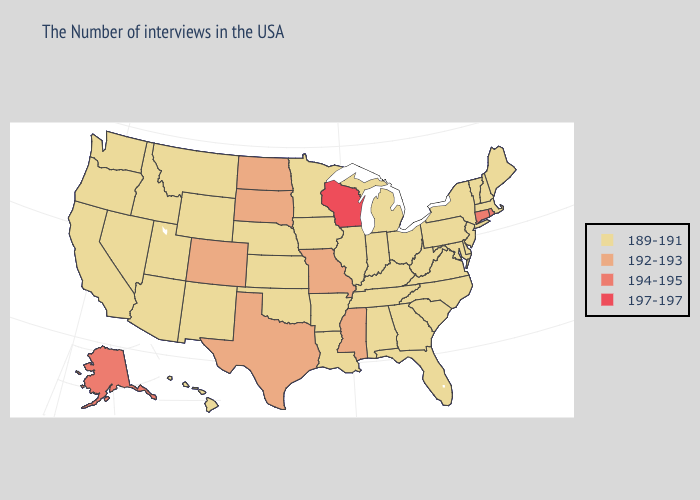What is the highest value in the West ?
Concise answer only. 194-195. Name the states that have a value in the range 197-197?
Give a very brief answer. Wisconsin. What is the lowest value in the Northeast?
Give a very brief answer. 189-191. Does Utah have the same value as Rhode Island?
Be succinct. No. Does West Virginia have the highest value in the USA?
Quick response, please. No. Which states have the lowest value in the USA?
Concise answer only. Maine, Massachusetts, New Hampshire, Vermont, New York, New Jersey, Delaware, Maryland, Pennsylvania, Virginia, North Carolina, South Carolina, West Virginia, Ohio, Florida, Georgia, Michigan, Kentucky, Indiana, Alabama, Tennessee, Illinois, Louisiana, Arkansas, Minnesota, Iowa, Kansas, Nebraska, Oklahoma, Wyoming, New Mexico, Utah, Montana, Arizona, Idaho, Nevada, California, Washington, Oregon, Hawaii. Does Arizona have the same value as Missouri?
Answer briefly. No. Which states have the lowest value in the USA?
Answer briefly. Maine, Massachusetts, New Hampshire, Vermont, New York, New Jersey, Delaware, Maryland, Pennsylvania, Virginia, North Carolina, South Carolina, West Virginia, Ohio, Florida, Georgia, Michigan, Kentucky, Indiana, Alabama, Tennessee, Illinois, Louisiana, Arkansas, Minnesota, Iowa, Kansas, Nebraska, Oklahoma, Wyoming, New Mexico, Utah, Montana, Arizona, Idaho, Nevada, California, Washington, Oregon, Hawaii. Does the map have missing data?
Write a very short answer. No. Does Illinois have the lowest value in the USA?
Concise answer only. Yes. What is the highest value in states that border Vermont?
Be succinct. 189-191. Name the states that have a value in the range 197-197?
Give a very brief answer. Wisconsin. Does Illinois have the highest value in the MidWest?
Give a very brief answer. No. Name the states that have a value in the range 194-195?
Answer briefly. Rhode Island, Connecticut, Alaska. Name the states that have a value in the range 189-191?
Concise answer only. Maine, Massachusetts, New Hampshire, Vermont, New York, New Jersey, Delaware, Maryland, Pennsylvania, Virginia, North Carolina, South Carolina, West Virginia, Ohio, Florida, Georgia, Michigan, Kentucky, Indiana, Alabama, Tennessee, Illinois, Louisiana, Arkansas, Minnesota, Iowa, Kansas, Nebraska, Oklahoma, Wyoming, New Mexico, Utah, Montana, Arizona, Idaho, Nevada, California, Washington, Oregon, Hawaii. 